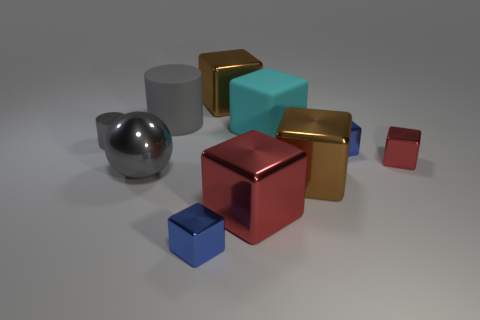Are there any other things that are the same shape as the big gray shiny object?
Provide a short and direct response. No. What is the color of the cylinder that is the same size as the ball?
Keep it short and to the point. Gray. What number of things are either large shiny blocks behind the large red object or big things in front of the tiny gray thing?
Provide a short and direct response. 4. Is the number of red cubes to the left of the big gray ball the same as the number of green shiny cylinders?
Offer a terse response. Yes. Is the size of the blue cube to the left of the big cyan matte object the same as the cylinder that is in front of the gray matte object?
Keep it short and to the point. Yes. What number of other objects are there of the same size as the sphere?
Make the answer very short. 5. There is a tiny blue object that is in front of the brown metallic thing in front of the big gray rubber object; are there any big matte objects that are to the right of it?
Give a very brief answer. Yes. Is there any other thing that has the same color as the large matte block?
Make the answer very short. No. There is a red object behind the big gray metal sphere; what size is it?
Provide a succinct answer. Small. What size is the matte object right of the blue block in front of the large shiny cube that is right of the big rubber cube?
Your answer should be very brief. Large. 